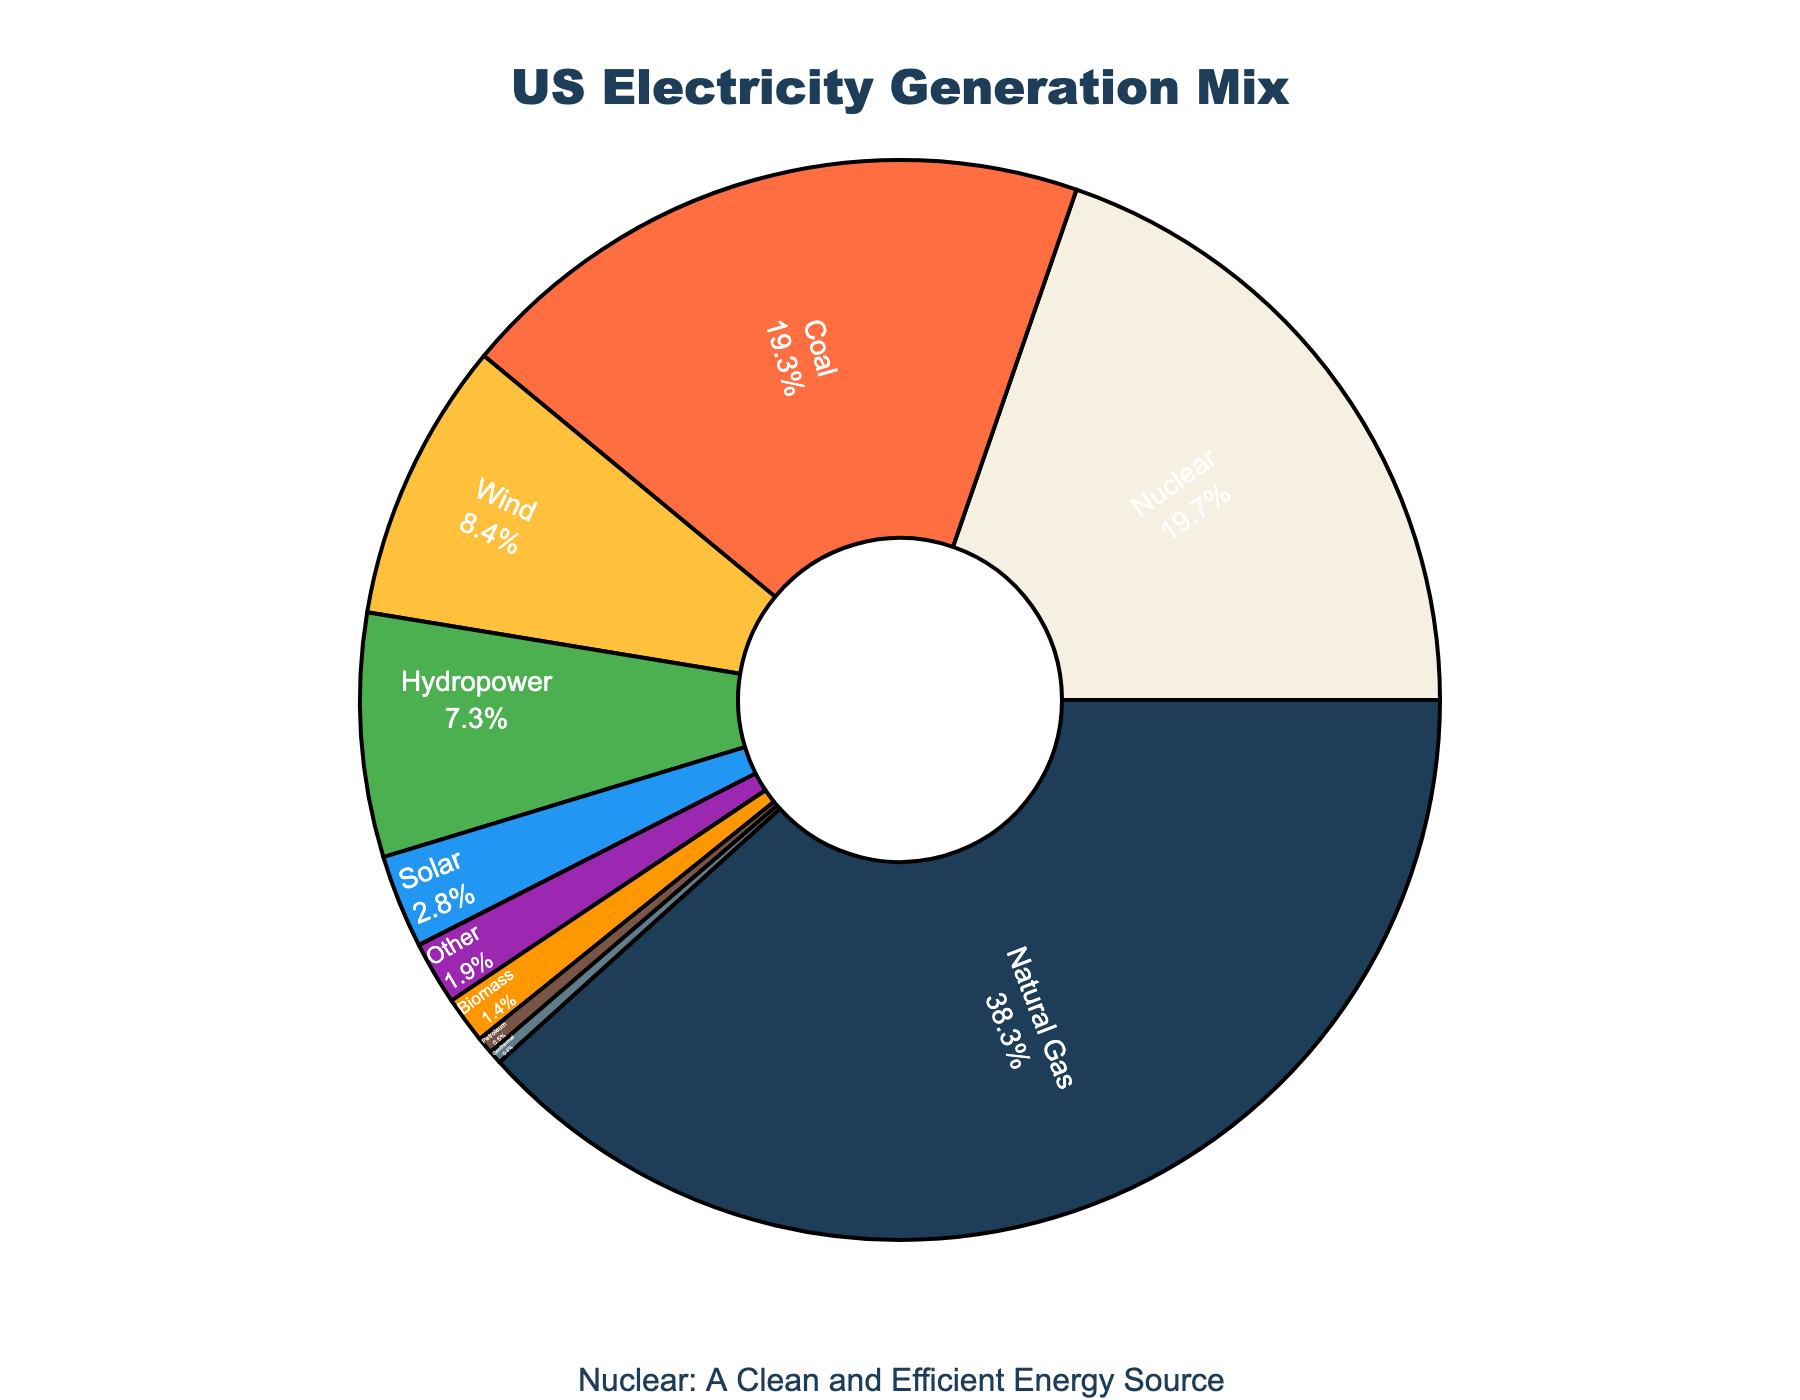What energy source contributes the most to the US electricity generation mix? The pie chart shows the largest segment labeled "Natural Gas" with a percentage value of 38.3%, indicating it's the energy source that contributes the most.
Answer: Natural Gas What is the combined percentage of energy generation from renewable sources like wind, hydropower, and solar? To find this, add the percentages of wind (8.4%), hydropower (7.3%), and solar (2.8%): 8.4 + 7.3 + 2.8 = 18.5%.
Answer: 18.5% How does the share of nuclear power compare to coal in the electricity generation mix? The pie chart shows nuclear power at 19.7% and coal at 19.3%. By comparing these values, we see that nuclear power has a slightly higher share than coal.
Answer: Nuclear has a slightly higher share Which energy source in the chart has the smallest contribution? The pie chart shows the smallest segment labeled "Geothermal" with a percentage value of 0.4%, indicating it's the energy source with the smallest contribution.
Answer: Geothermal Which two energy sources combined have a larger share than nuclear power alone? Coal (19.3%) and wind (8.4%) combined result in 19.3 + 8.4 = 27.7%, which is larger than nuclear (19.7%).
Answer: Coal and Wind Compare the percentage contribution of solar and biomass. The pie chart shows solar at 2.8% and biomass at 1.4%. Solar has exactly twice the contribution of biomass.
Answer: Solar is twice biomass What is the total percentage of energy sources (other than nuclear) which have a share greater than 10%? Natural Gas (38.3%) and Coal (19.3%) are the only other sources with shares greater than 10%. Summing these, 38.3 + 19.3 = 57.6%.
Answer: 57.6% What energy source is represented by the green segment in the pie chart? The green segment in the chart corresponds to hydropower with a percentage value of 7.3%, signifying it's the energy source represented by green.
Answer: Hydropower If solar and geothermal sources were combined, would their combined share exceed biomass? The chart shows solar with 2.8% and geothermal with 0.4%. Combined, 2.8 + 0.4 = 3.2%, which is greater than biomass (1.4%).
Answer: Yes What is the difference in contribution between the largest and the smallest energy sources in the chart? The largest source is natural gas at 38.3%, and the smallest is geothermal at 0.4%. The difference is 38.3 - 0.4 = 37.9%.
Answer: 37.9% 